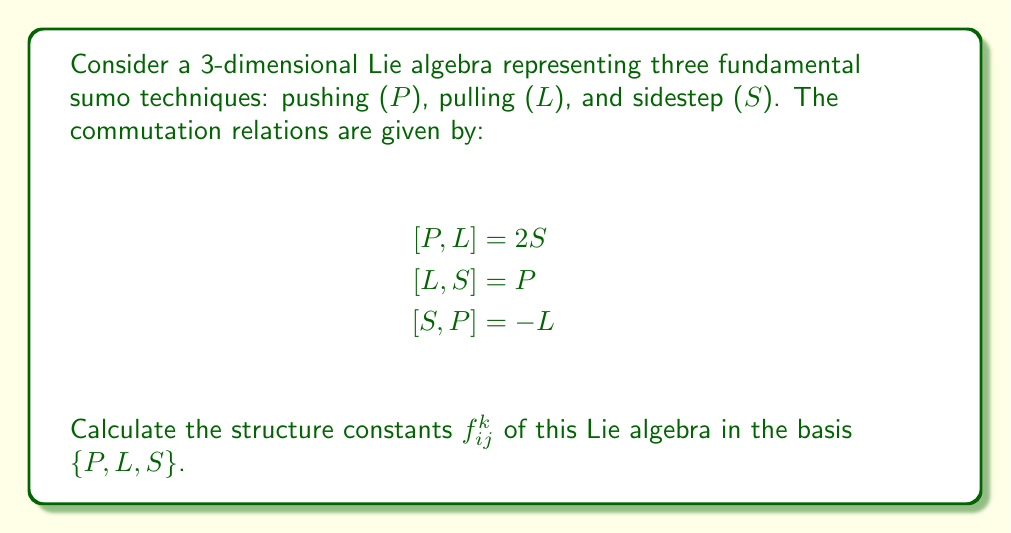Provide a solution to this math problem. To calculate the structure constants of this Lie algebra, we need to express the commutation relations in terms of the structure constants $f_{ij}^k$. The general form of the commutation relation is:

$$[X_i, X_j] = \sum_k f_{ij}^k X_k$$

Where $X_i$, $X_j$, and $X_k$ are basis elements of the Lie algebra.

Let's assign indices to our basis elements:
$X_1 = P$, $X_2 = L$, $X_3 = S$

Now, we can express each commutation relation in terms of structure constants:

1) $[P, L] = 2S$:
   $[X_1, X_2] = 2X_3$
   This implies $f_{12}^3 = 2$ (and $f_{21}^3 = -2$ due to antisymmetry)

2) $[L, S] = P$:
   $[X_2, X_3] = X_1$
   This implies $f_{23}^1 = 1$ (and $f_{32}^1 = -1$)

3) $[S, P] = -L$:
   $[X_3, X_1] = -X_2$
   This implies $f_{31}^2 = -1$ (and $f_{13}^2 = 1$)

All other structure constants are zero.

The complete set of non-zero structure constants is:
$$f_{12}^3 = 2, f_{21}^3 = -2$$
$$f_{23}^1 = 1, f_{32}^1 = -1$$
$$f_{31}^2 = -1, f_{13}^2 = 1$$
Answer: The non-zero structure constants are:
$$f_{12}^3 = 2, f_{21}^3 = -2, f_{23}^1 = 1, f_{32}^1 = -1, f_{31}^2 = -1, f_{13}^2 = 1$$
All other structure constants are zero. 